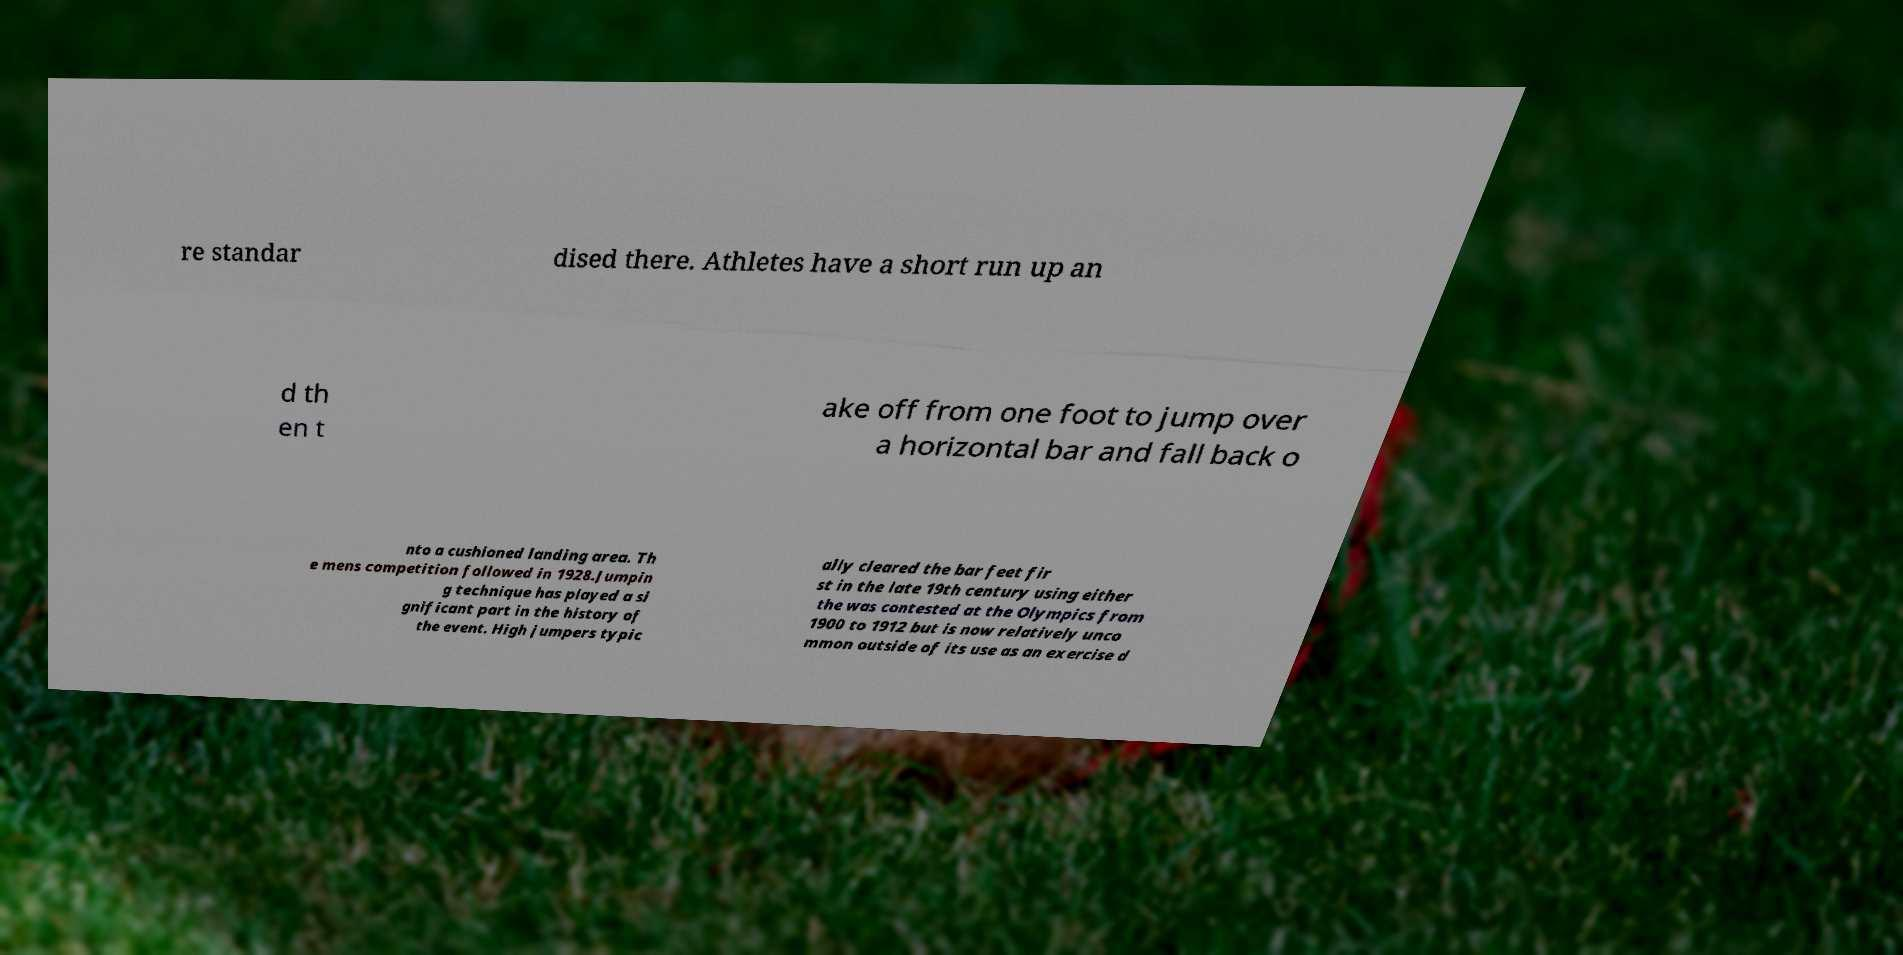Can you read and provide the text displayed in the image?This photo seems to have some interesting text. Can you extract and type it out for me? re standar dised there. Athletes have a short run up an d th en t ake off from one foot to jump over a horizontal bar and fall back o nto a cushioned landing area. Th e mens competition followed in 1928.Jumpin g technique has played a si gnificant part in the history of the event. High jumpers typic ally cleared the bar feet fir st in the late 19th century using either the was contested at the Olympics from 1900 to 1912 but is now relatively unco mmon outside of its use as an exercise d 